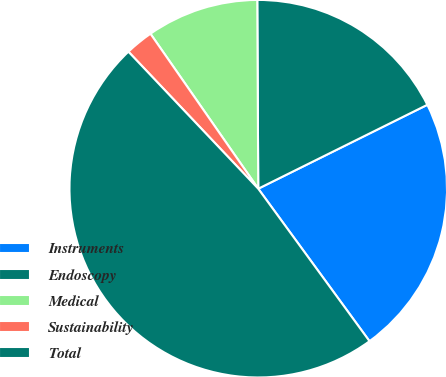Convert chart to OTSL. <chart><loc_0><loc_0><loc_500><loc_500><pie_chart><fcel>Instruments<fcel>Endoscopy<fcel>Medical<fcel>Sustainability<fcel>Total<nl><fcel>22.3%<fcel>17.75%<fcel>9.59%<fcel>2.4%<fcel>47.96%<nl></chart> 